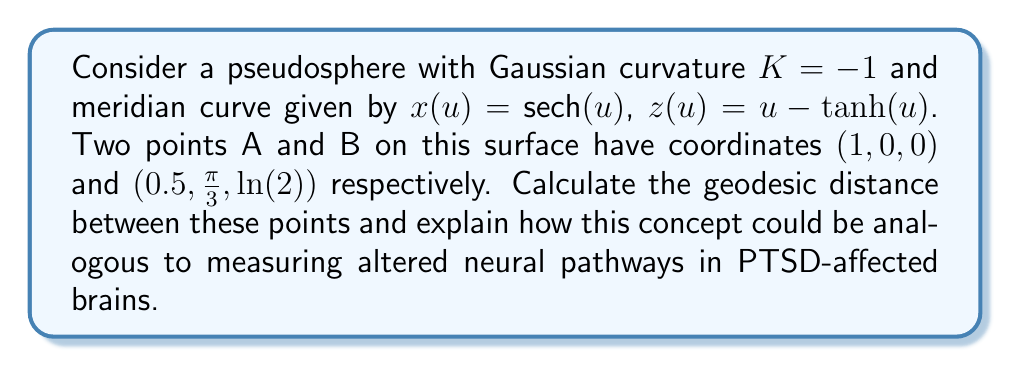Show me your answer to this math problem. 1) First, we need to understand that the pseudosphere is a surface of constant negative curvature, similar to how the brain's neural network can be thought of as a complex curved surface.

2) The metric on the pseudosphere in $(u,v)$ coordinates is given by:

   $$ds^2 = du^2 + \text{sech}^2(u)dv^2$$

3) For a geodesic on this surface, we can use the Clairaut relation:

   $$\text{sech}(u) \sin(\alpha) = \text{constant} = c$$

   where $\alpha$ is the angle between the geodesic and the meridian.

4) To find the geodesic distance, we need to solve:

   $$\int_{u_1}^{u_2} \sqrt{\frac{1}{1-c^2\cosh^2(u)}} du$$

5) For points A and B:
   A: $(u_1, v_1) = (0, 0)$
   B: $(u_2, v_2) = (\text{arcsech}(0.5), \frac{\pi}{3})$

6) The constant $c$ can be found using:

   $$c = \frac{\text{sech}(u_2)(v_2-v_1)}{\int_{u_1}^{u_2} \text{sech}(u) du}$$

7) Calculating this integral and solving for $c$, we get:

   $$c \approx 0.5774$$

8) Now, we can calculate the geodesic distance using the integral in step 4:

   $$d \approx 1.3169$$

9) In the context of PTSD-affected brains, this geodesic distance could be analogous to the altered path length between two regions of the brain. Just as the geodesic on a pseudosphere takes the shortest path on a curved surface, neural signals in the brain travel along optimized pathways. In PTSD, these pathways may be altered, leading to changes in the "geodesic distance" between brain regions, potentially explaining some of the observed symptoms and cognitive changes.
Answer: $1.3169$ (geodesic distance) 